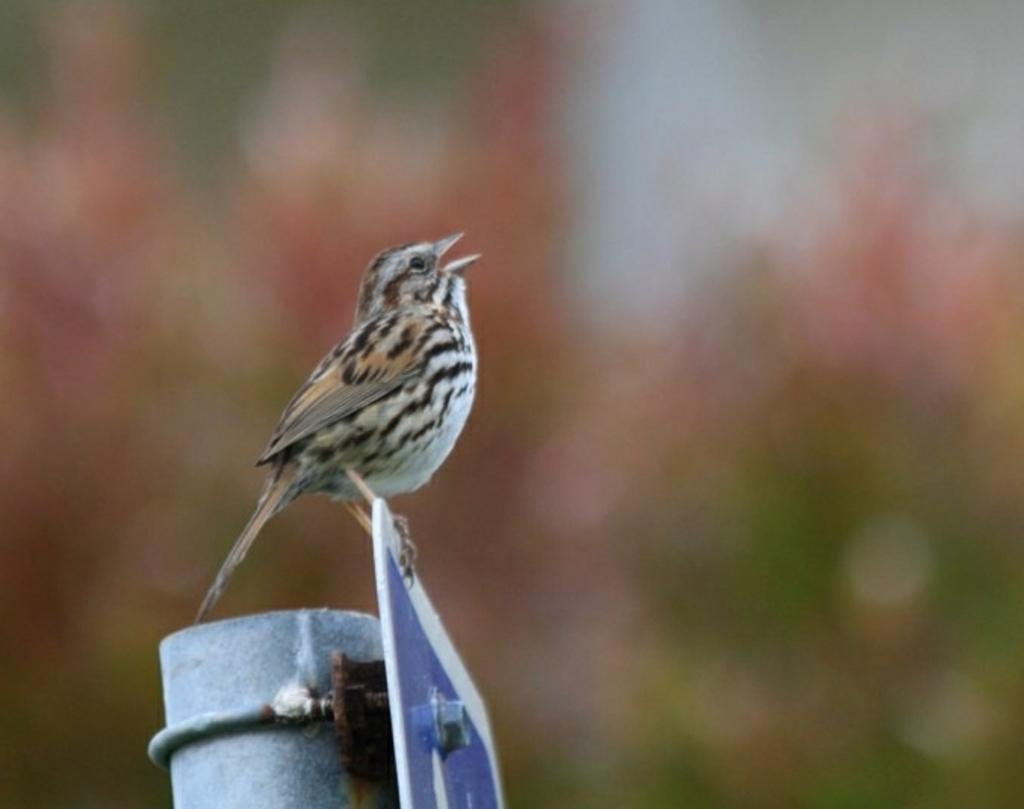What type of animal can be seen in the image? There is a bird in the image. What is the bird standing on? The bird is standing on a board. How is the board positioned in the image? The board is attached to a pole. What type of bead is the bird holding in its hands in the image? There is no bead or hands present in the image; the bird is standing on a board attached to a pole. 